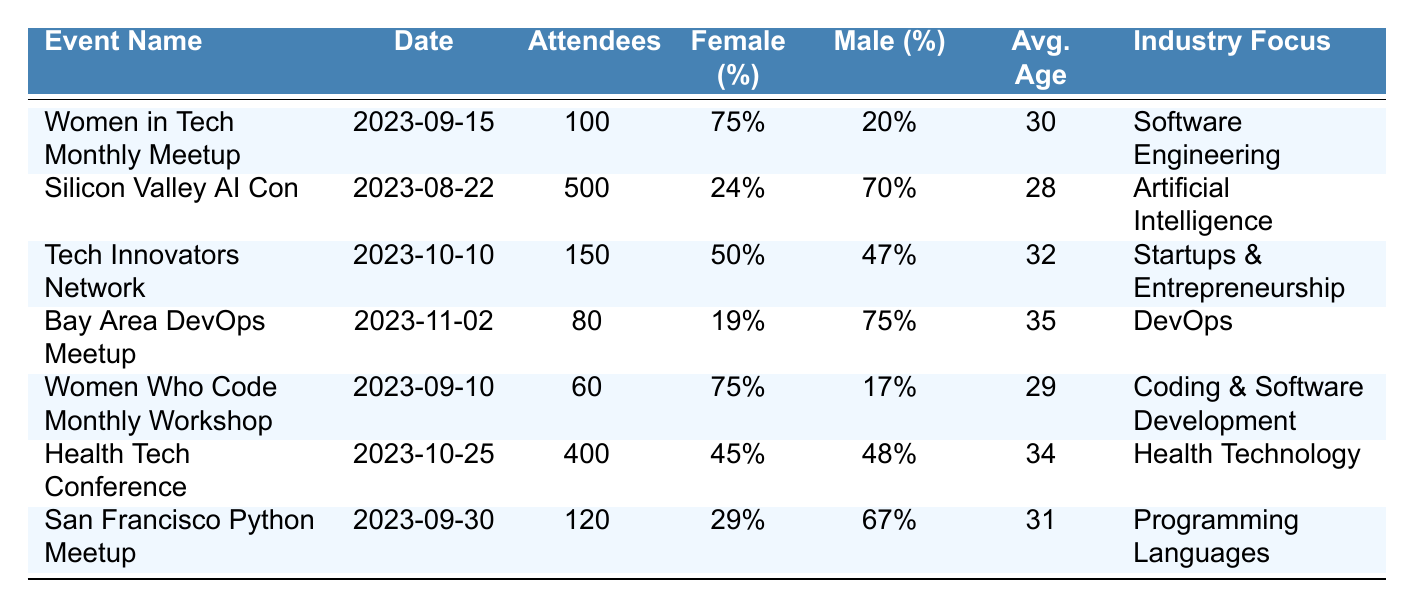What is the event with the highest attendance? By comparing the "Attendees" column for each event, the "Silicon Valley AI Con" has the highest attendance at 500 participants.
Answer: Silicon Valley AI Con What is the average age of attendees at the "Women Who Code Monthly Workshop"? The table lists the "average_age" for the "Women Who Code Monthly Workshop" as 29 years.
Answer: 29 How many total female attendees were present across all events? Adding the female attendance from each event: 75 + 120 + 75 + 15 + 45 + 180 + 35 = 540.
Answer: 540 Which event had the lowest percentage of female attendance? Evaluating the "Female (%)" column, the "Bay Area DevOps Meetup" had the lowest percentage of female attendance at 19%.
Answer: Bay Area DevOps Meetup Is the average age of attendees generally higher in events focused on health technology compared to software engineering? The "Health Tech Conference" has an average age of 34, while the "Women in Tech Monthly Meetup" has an average age of 30. Thus, the health technology event has a higher average age.
Answer: Yes What is the total number of attendees at events that have an industry focus on startups and health technology? The events with "Startups & Entrepreneurship" (150) and "Health Technology" (400) add up to 150 + 400 = 550 attendees in total.
Answer: 550 Is there any event that has more than 100 male attendees? The events "Silicon Valley AI Con" (350) and "Health Tech Conference" (190) each have male attendance exceeding 100 individuals.
Answer: Yes What percentage of the total attendees at all events were male? The total number of attendees across all events is 100 + 500 + 150 + 80 + 60 + 400 + 120 = 1,410. The total male attendance is 20 + 350 + 70 + 60 + 10 + 190 + 80 = 780. The percentage is (780 / 1410) * 100 ≈ 55.3%.
Answer: Approximately 55.3% Which event has the largest male-to-female attendance ratio? Calculating the ratio of male to female attendance for each event: (20/75), (350/120), (70/75), (60/15), (10/45), (190/180), (80/35). The "Silicon Valley AI Con" has a ratio of about 2.92, the highest among all events.
Answer: Silicon Valley AI Con How many events had more than 70% female attendance? The "Women in Tech Monthly Meetup" (75%) and "Women Who Code Monthly Workshop" (75%) both have over 70% female attendance.
Answer: 2 